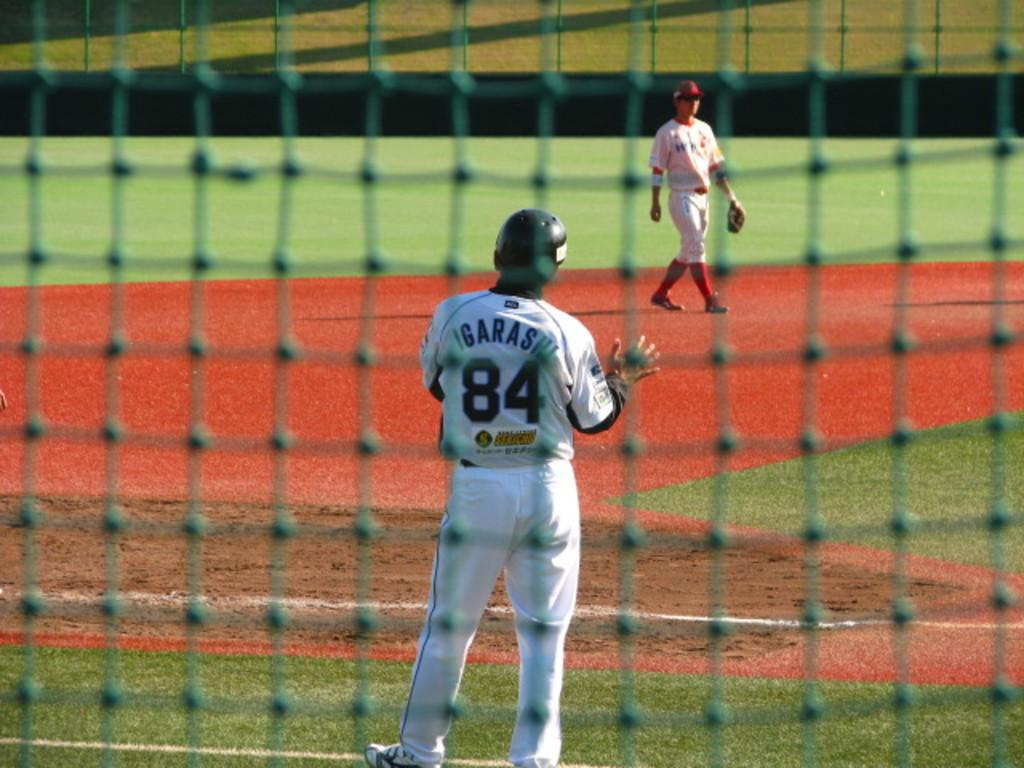Provide a one-sentence caption for the provided image. A baseball player called Igarashi wears a white strip and waits for the ball to be thrown to him. 